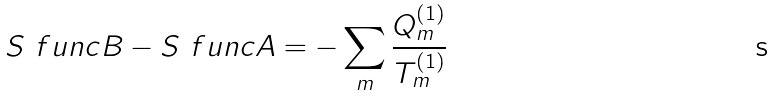Convert formula to latex. <formula><loc_0><loc_0><loc_500><loc_500>S \ f u n c { B } - S \ f u n c { A } = - \sum _ { m } \frac { Q ^ { ( 1 ) } _ { m } } { T ^ { ( 1 ) } _ { m } }</formula> 